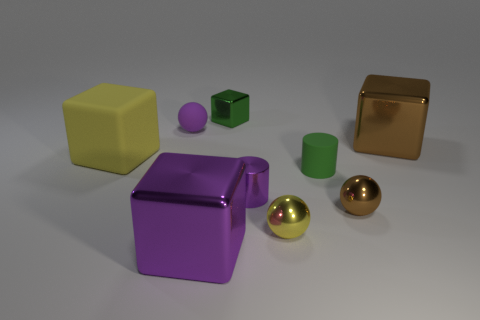Does the rubber cylinder have the same color as the tiny metallic block?
Your answer should be very brief. Yes. What size is the cylinder that is the same material as the small brown thing?
Ensure brevity in your answer.  Small. Is the number of tiny green cubes greater than the number of small gray metal blocks?
Provide a succinct answer. Yes. There is a brown sphere that is the same size as the metallic cylinder; what material is it?
Keep it short and to the point. Metal. Do the thing that is right of the brown sphere and the large yellow matte block have the same size?
Keep it short and to the point. Yes. What number of cylinders are either big brown metallic things or green things?
Your answer should be compact. 1. There is a yellow thing that is right of the yellow block; what is its material?
Your answer should be compact. Metal. Is the number of large purple metal things less than the number of brown objects?
Offer a very short reply. Yes. What is the size of the block that is in front of the tiny purple matte sphere and on the right side of the big purple metallic cube?
Your answer should be compact. Large. How big is the rubber sphere right of the matte thing left of the purple ball that is in front of the tiny green shiny cube?
Provide a succinct answer. Small. 